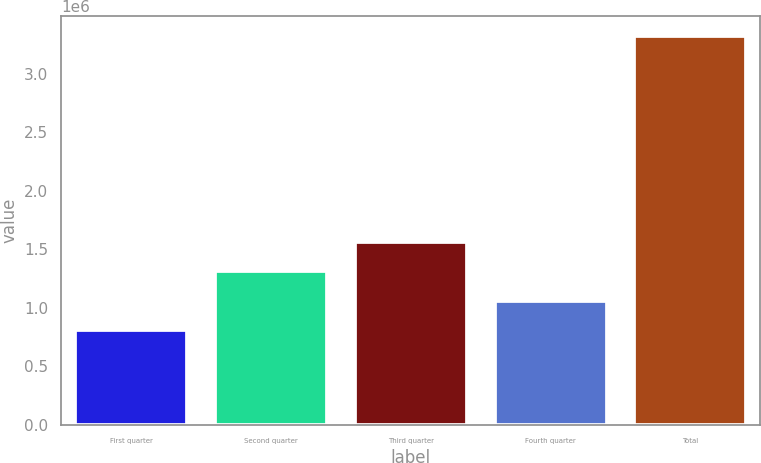Convert chart. <chart><loc_0><loc_0><loc_500><loc_500><bar_chart><fcel>First quarter<fcel>Second quarter<fcel>Third quarter<fcel>Fourth quarter<fcel>Total<nl><fcel>806326<fcel>1.31028e+06<fcel>1.56226e+06<fcel>1.0583e+06<fcel>3.32611e+06<nl></chart> 